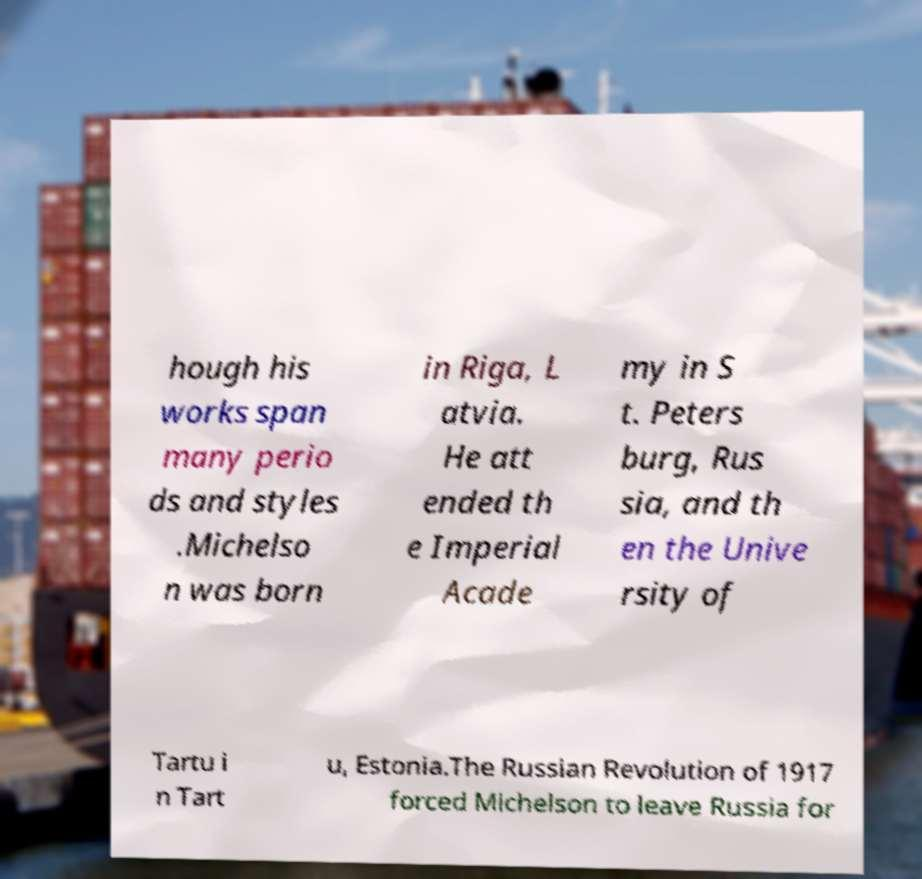Please read and relay the text visible in this image. What does it say? hough his works span many perio ds and styles .Michelso n was born in Riga, L atvia. He att ended th e Imperial Acade my in S t. Peters burg, Rus sia, and th en the Unive rsity of Tartu i n Tart u, Estonia.The Russian Revolution of 1917 forced Michelson to leave Russia for 